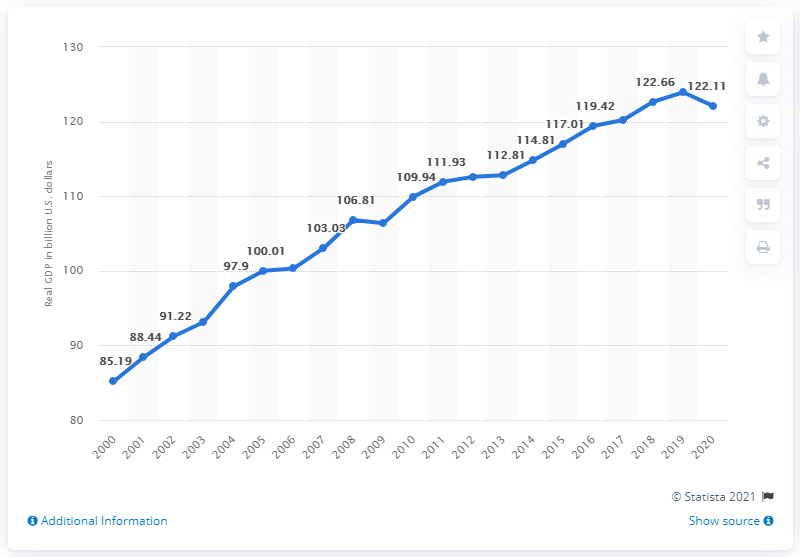Specify some key components in this picture. In 2020, the Gross Domestic Product of the District of Columbia was 122.11 billion dollars. In the previous year, the Gross Domestic Product of the District of Columbia was 123.93... 